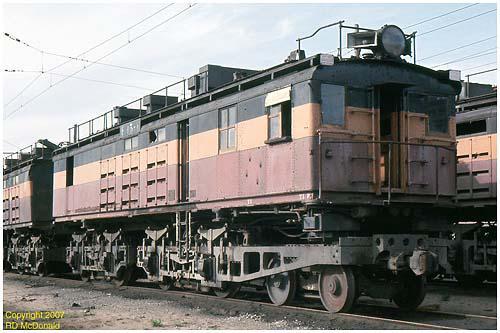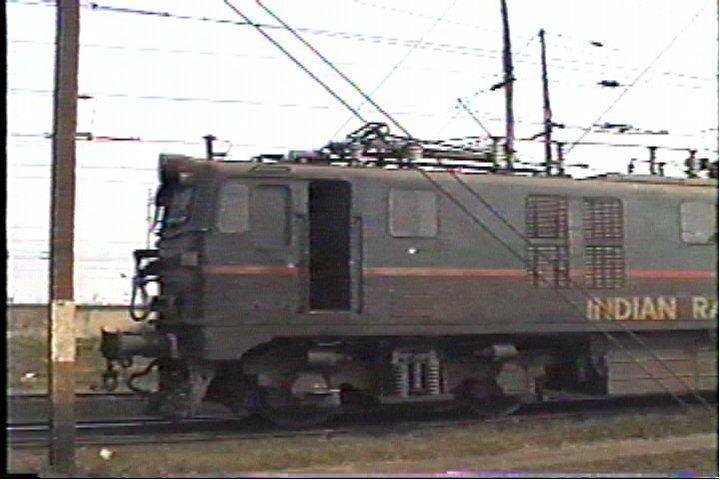The first image is the image on the left, the second image is the image on the right. For the images shown, is this caption "The right image includes at least one element with a pattern of bold diagonal lines near a red-orange train car." true? Answer yes or no. No. The first image is the image on the left, the second image is the image on the right. Analyze the images presented: Is the assertion "One train car is mostly orange, with diagonal stripes at it's nose." valid? Answer yes or no. No. 